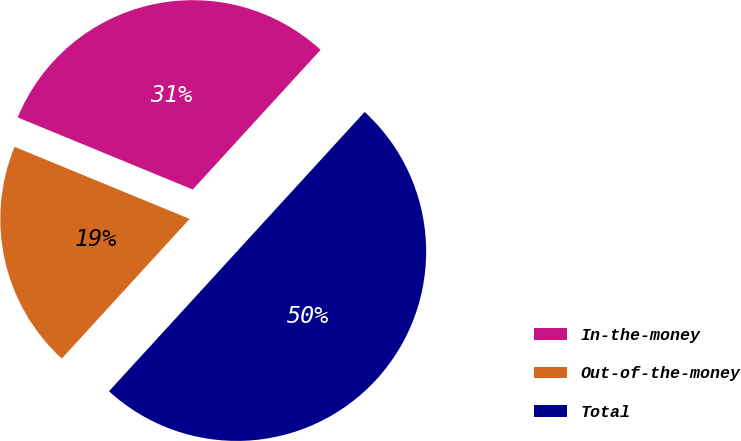Convert chart to OTSL. <chart><loc_0><loc_0><loc_500><loc_500><pie_chart><fcel>In-the-money<fcel>Out-of-the-money<fcel>Total<nl><fcel>30.58%<fcel>19.42%<fcel>50.0%<nl></chart> 